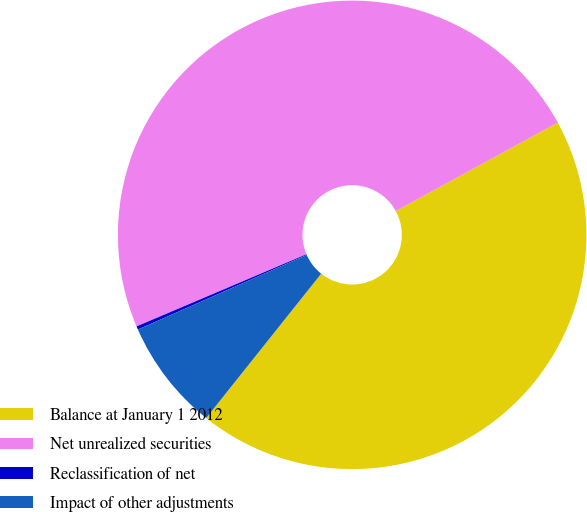Convert chart. <chart><loc_0><loc_0><loc_500><loc_500><pie_chart><fcel>Balance at January 1 2012<fcel>Net unrealized securities<fcel>Reclassification of net<fcel>Impact of other adjustments<nl><fcel>43.67%<fcel>48.44%<fcel>0.23%<fcel>7.67%<nl></chart> 